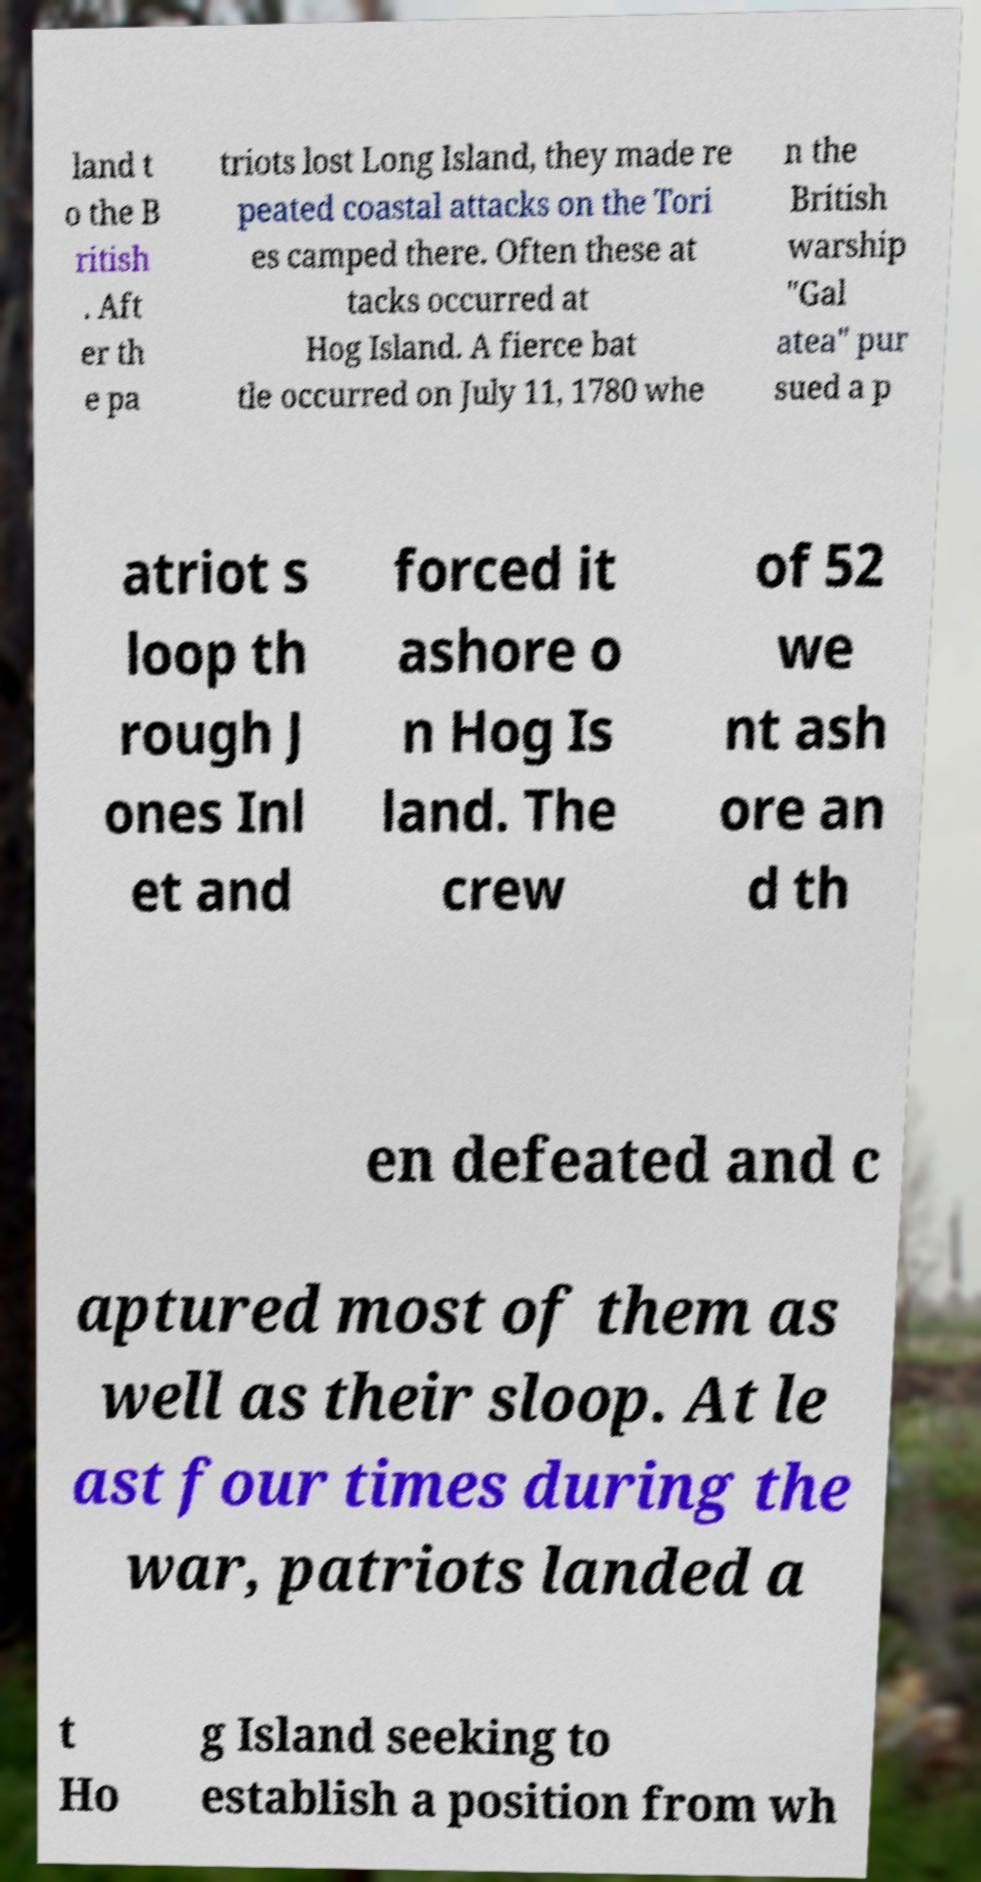There's text embedded in this image that I need extracted. Can you transcribe it verbatim? land t o the B ritish . Aft er th e pa triots lost Long Island, they made re peated coastal attacks on the Tori es camped there. Often these at tacks occurred at Hog Island. A fierce bat tle occurred on July 11, 1780 whe n the British warship "Gal atea" pur sued a p atriot s loop th rough J ones Inl et and forced it ashore o n Hog Is land. The crew of 52 we nt ash ore an d th en defeated and c aptured most of them as well as their sloop. At le ast four times during the war, patriots landed a t Ho g Island seeking to establish a position from wh 